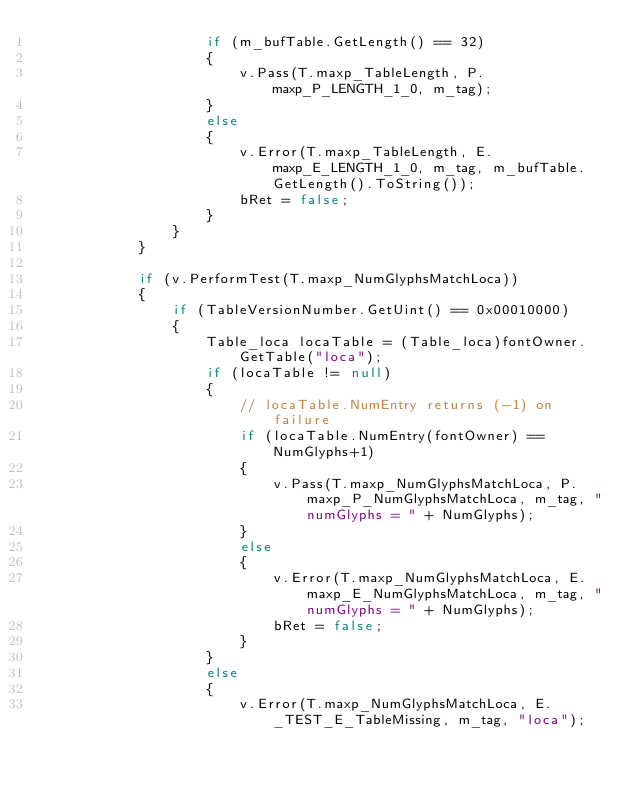Convert code to text. <code><loc_0><loc_0><loc_500><loc_500><_C#_>                    if (m_bufTable.GetLength() == 32)
                    {
                        v.Pass(T.maxp_TableLength, P.maxp_P_LENGTH_1_0, m_tag);
                    }
                    else
                    {
                        v.Error(T.maxp_TableLength, E.maxp_E_LENGTH_1_0, m_tag, m_bufTable.GetLength().ToString());
                        bRet = false;
                    }
                }
            }

            if (v.PerformTest(T.maxp_NumGlyphsMatchLoca))
            {
                if (TableVersionNumber.GetUint() == 0x00010000)
                {
                    Table_loca locaTable = (Table_loca)fontOwner.GetTable("loca");
                    if (locaTable != null)
                    {
                        // locaTable.NumEntry returns (-1) on failure
                        if (locaTable.NumEntry(fontOwner) == NumGlyphs+1)
                        {
                            v.Pass(T.maxp_NumGlyphsMatchLoca, P.maxp_P_NumGlyphsMatchLoca, m_tag, "numGlyphs = " + NumGlyphs);
                        }
                        else
                        {
                            v.Error(T.maxp_NumGlyphsMatchLoca, E.maxp_E_NumGlyphsMatchLoca, m_tag, "numGlyphs = " + NumGlyphs);
                            bRet = false;
                        }
                    }
                    else
                    {
                        v.Error(T.maxp_NumGlyphsMatchLoca, E._TEST_E_TableMissing, m_tag, "loca");</code> 